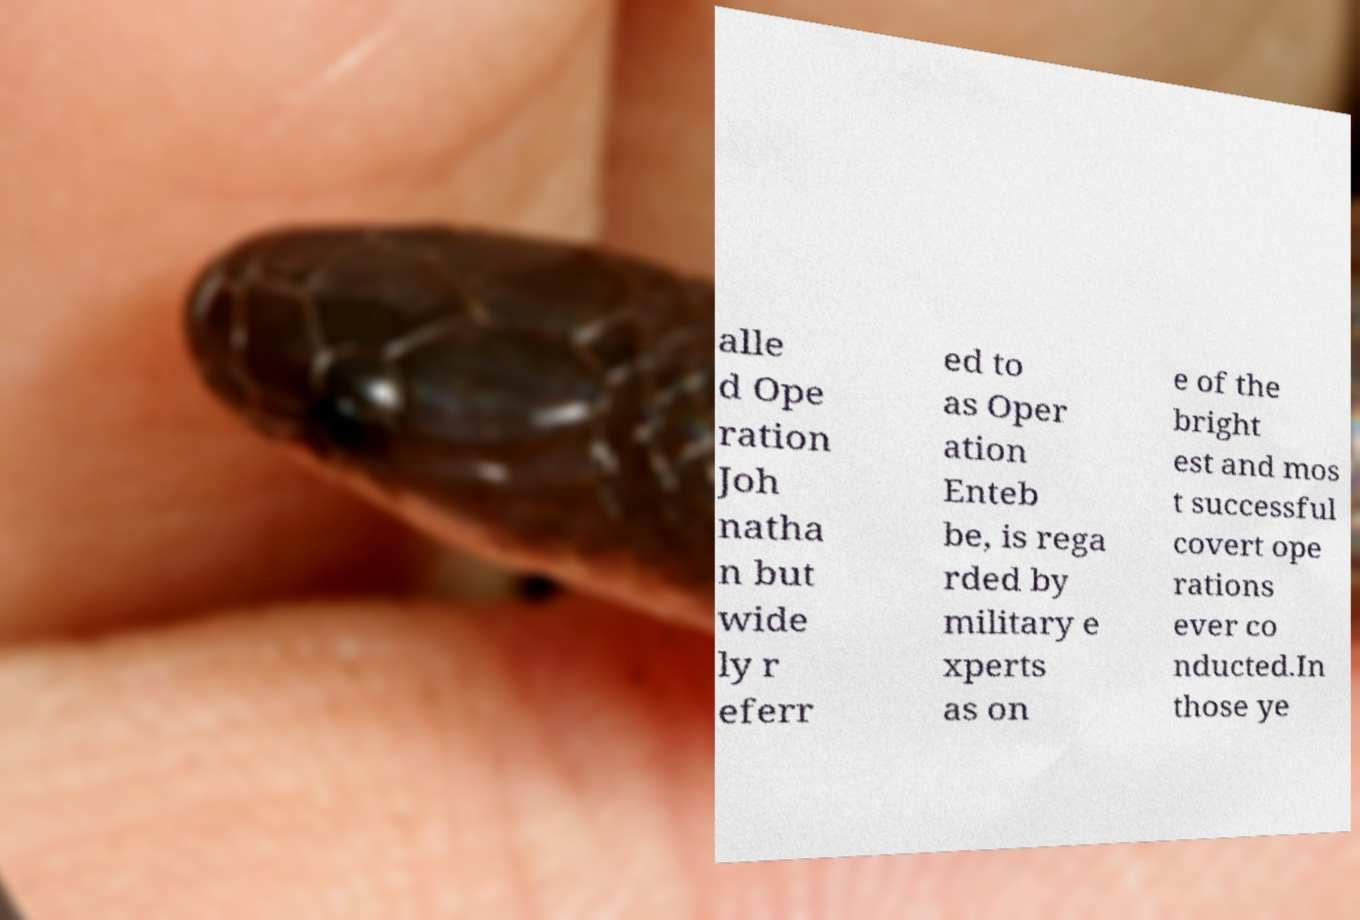There's text embedded in this image that I need extracted. Can you transcribe it verbatim? alle d Ope ration Joh natha n but wide ly r eferr ed to as Oper ation Enteb be, is rega rded by military e xperts as on e of the bright est and mos t successful covert ope rations ever co nducted.In those ye 